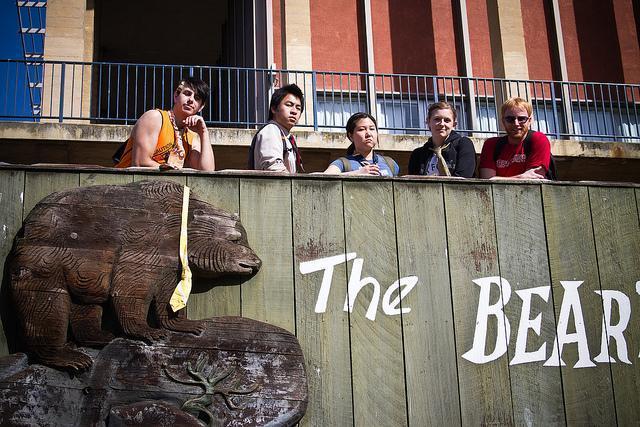How many people are posing?
Give a very brief answer. 5. How many people are there?
Give a very brief answer. 5. How many bikes are?
Give a very brief answer. 0. 